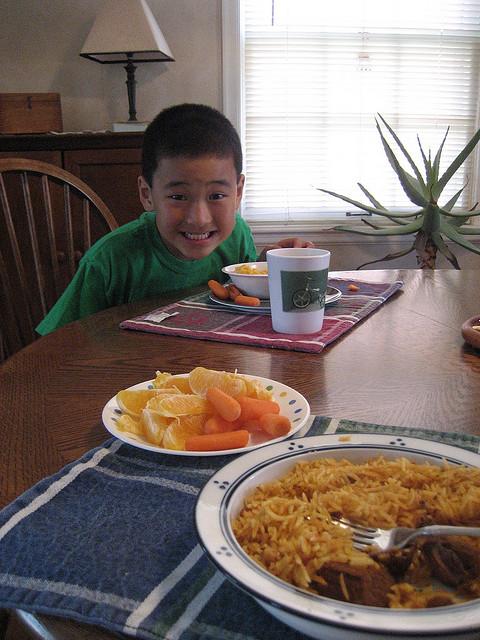Will this child own a pizzeria?
Keep it brief. No. Is the boy hungry?
Short answer required. Yes. Is the boy happy?
Write a very short answer. Yes. What is the family having for dinner?
Write a very short answer. Rice. What are the white square things on the counter in the background?
Answer briefly. Unknown. What is he holding in his hand?
Concise answer only. Spoon. What is the fruit?
Answer briefly. Orange. 